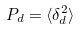Convert formula to latex. <formula><loc_0><loc_0><loc_500><loc_500>P _ { d } = \langle \delta _ { d } ^ { 2 } \rangle</formula> 